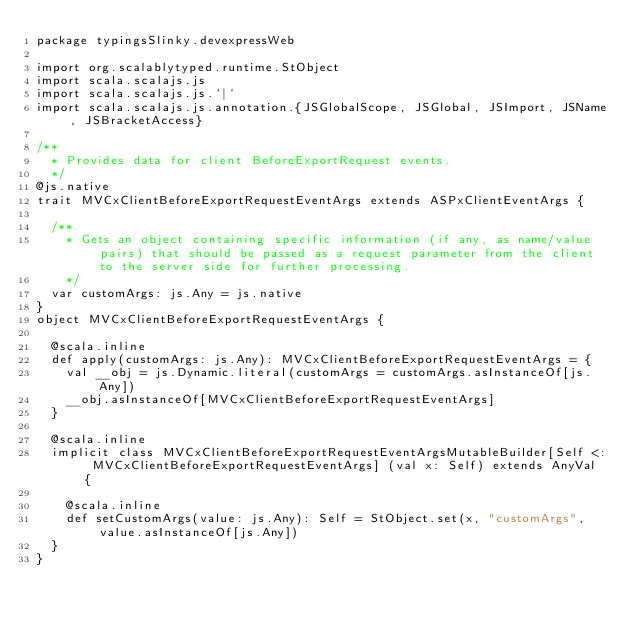Convert code to text. <code><loc_0><loc_0><loc_500><loc_500><_Scala_>package typingsSlinky.devexpressWeb

import org.scalablytyped.runtime.StObject
import scala.scalajs.js
import scala.scalajs.js.`|`
import scala.scalajs.js.annotation.{JSGlobalScope, JSGlobal, JSImport, JSName, JSBracketAccess}

/**
  * Provides data for client BeforeExportRequest events.
  */
@js.native
trait MVCxClientBeforeExportRequestEventArgs extends ASPxClientEventArgs {
  
  /**
    * Gets an object containing specific information (if any, as name/value pairs) that should be passed as a request parameter from the client to the server side for further processing.
    */
  var customArgs: js.Any = js.native
}
object MVCxClientBeforeExportRequestEventArgs {
  
  @scala.inline
  def apply(customArgs: js.Any): MVCxClientBeforeExportRequestEventArgs = {
    val __obj = js.Dynamic.literal(customArgs = customArgs.asInstanceOf[js.Any])
    __obj.asInstanceOf[MVCxClientBeforeExportRequestEventArgs]
  }
  
  @scala.inline
  implicit class MVCxClientBeforeExportRequestEventArgsMutableBuilder[Self <: MVCxClientBeforeExportRequestEventArgs] (val x: Self) extends AnyVal {
    
    @scala.inline
    def setCustomArgs(value: js.Any): Self = StObject.set(x, "customArgs", value.asInstanceOf[js.Any])
  }
}
</code> 